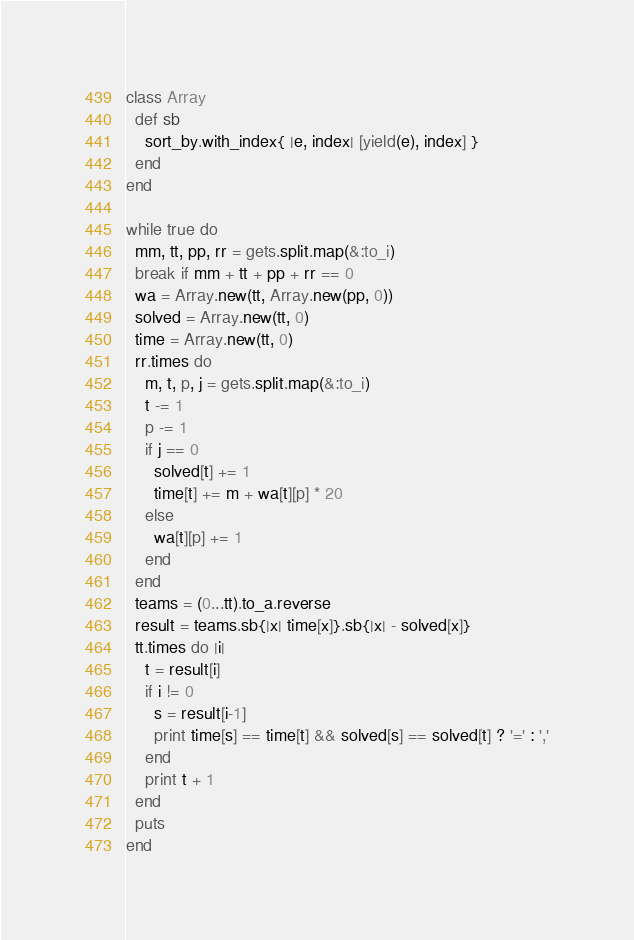<code> <loc_0><loc_0><loc_500><loc_500><_Ruby_>class Array
  def sb
    sort_by.with_index{ |e, index| [yield(e), index] }
  end
end

while true do
  mm, tt, pp, rr = gets.split.map(&:to_i)
  break if mm + tt + pp + rr == 0
  wa = Array.new(tt, Array.new(pp, 0))
  solved = Array.new(tt, 0)
  time = Array.new(tt, 0)
  rr.times do
    m, t, p, j = gets.split.map(&:to_i)
    t -= 1
    p -= 1
    if j == 0
      solved[t] += 1
      time[t] += m + wa[t][p] * 20
    else
      wa[t][p] += 1
    end
  end
  teams = (0...tt).to_a.reverse
  result = teams.sb{|x| time[x]}.sb{|x| - solved[x]}
  tt.times do |i|
    t = result[i]
    if i != 0
      s = result[i-1]
      print time[s] == time[t] && solved[s] == solved[t] ? '=' : ','
    end
    print t + 1
  end
  puts
end</code> 